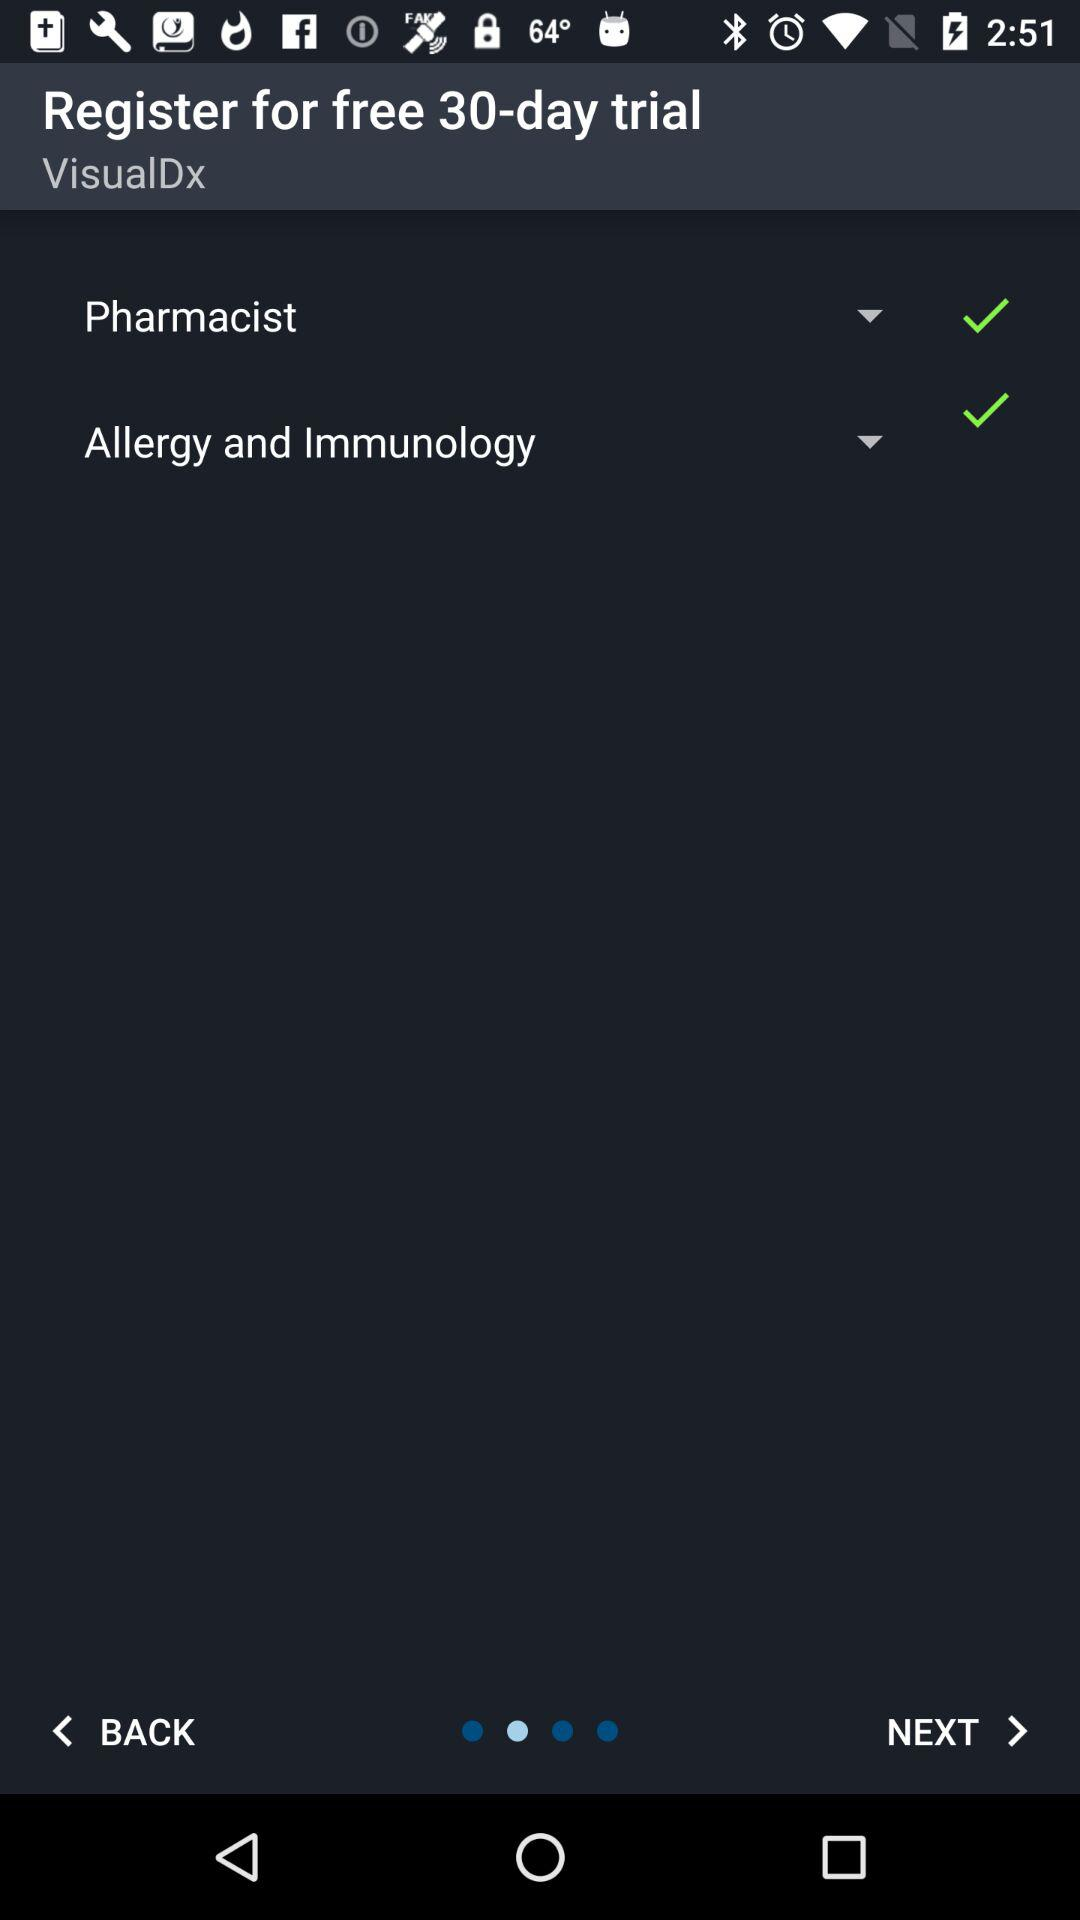How long does the free trial last? The free trial lasts for 30 days. 